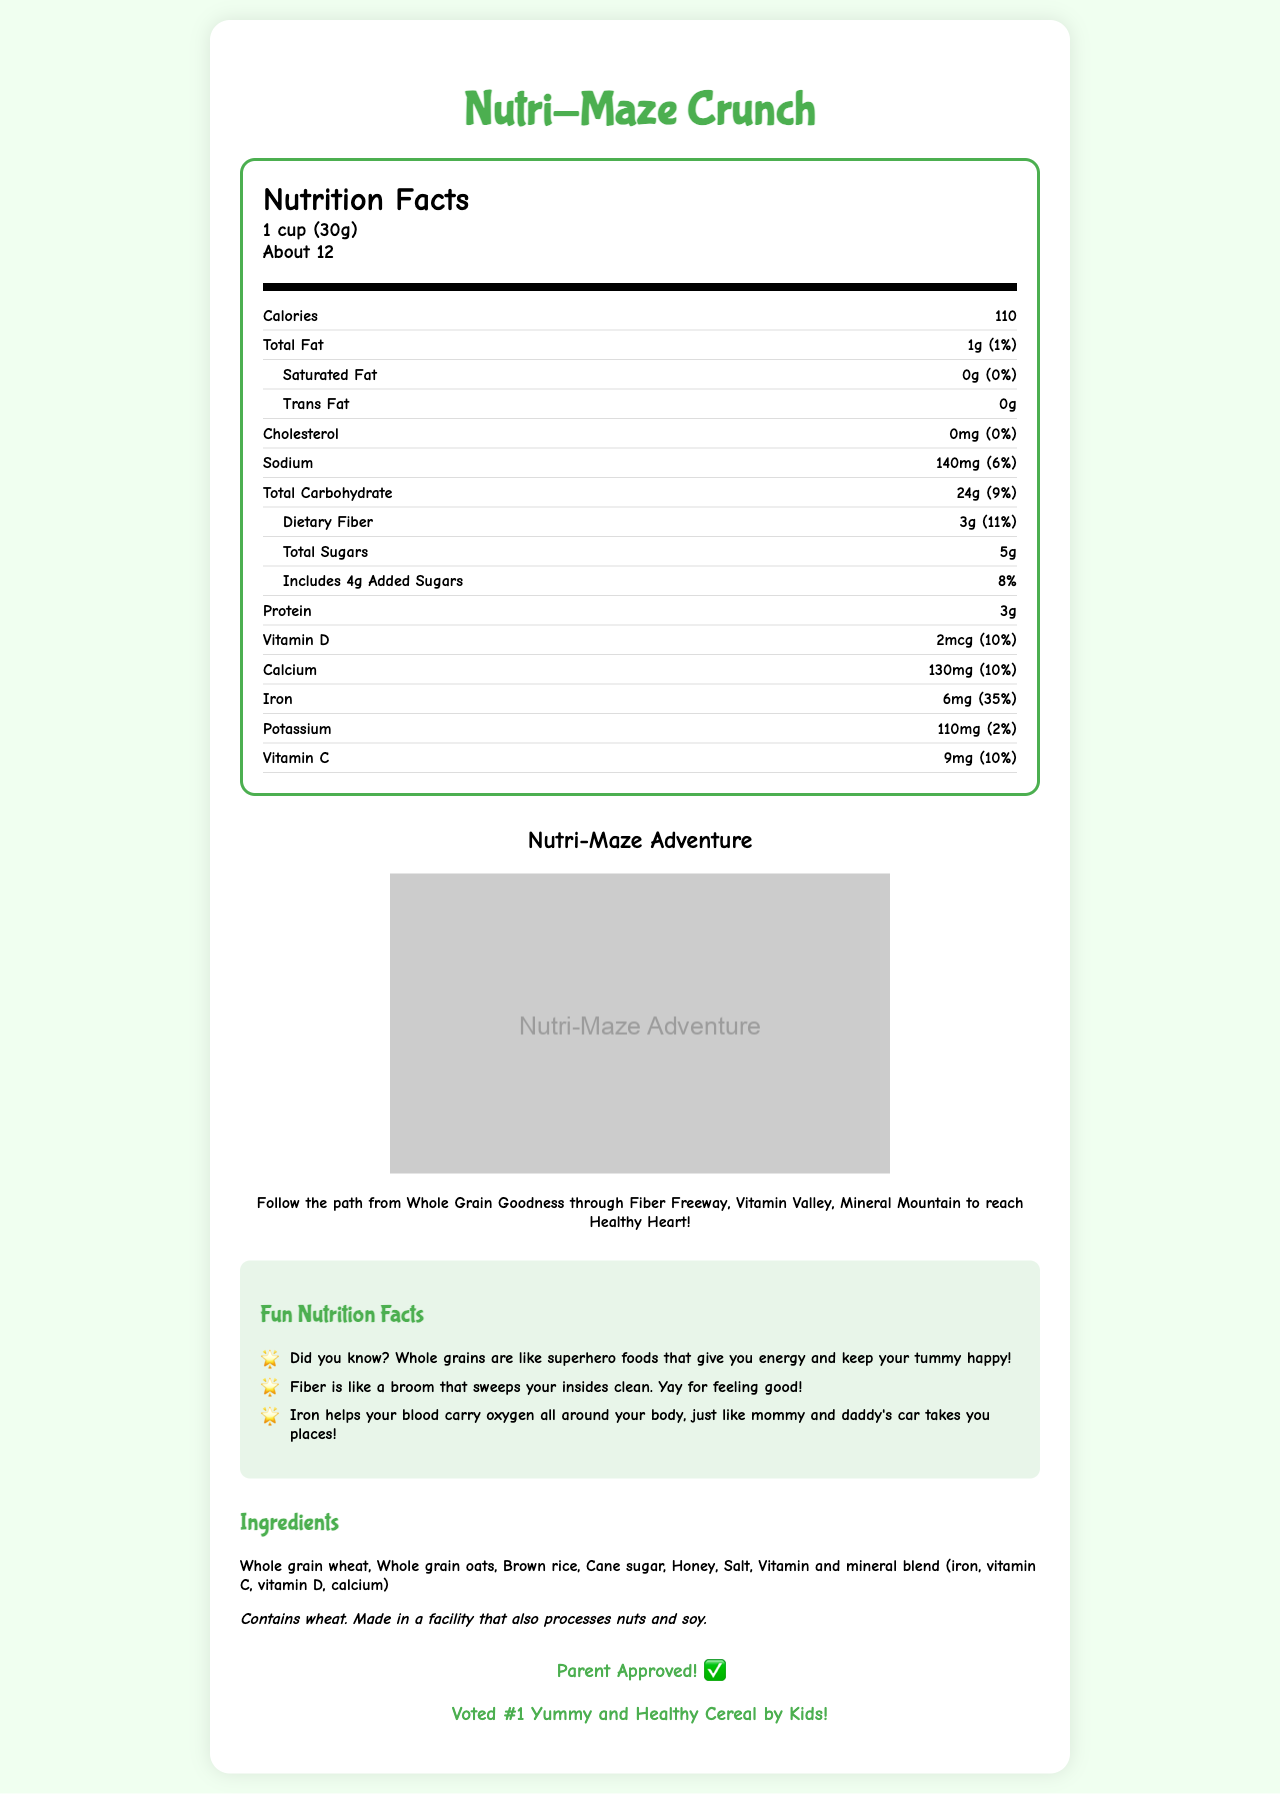what is the serving size? The serving size is clearly listed at the top of the nutrition facts label as "1 cup (30g)".
Answer: 1 cup (30g) how many calories are in one serving? The calories per serving is specified right after the serving size, indicating 110 calories per serving.
Answer: 110 which ingredient is listed first? The first ingredient listed in the ingredients section is "Whole grain wheat", indicating it is the main ingredient.
Answer: Whole grain wheat what percentage of daily value does iron provide? The nutrition label specifically indicates that iron provides 35% of the daily value.
Answer: 35% Does this product contain any allergens? The allergen information states that the product contains wheat and is made in a facility that also processes nuts and soy.
Answer: Yes What are the benefits of fiber mentioned in the fun facts? The fun facts mention that fiber keeps your tummy happy and acts like a broom that sweeps your insides clean.
Answer: keeps your tummy happy, acts like a broom that sweeps your insides clean What are the fun facts about whole grains? The fun facts section states, "Whole grains are like superhero foods that give you energy and keep your tummy happy!"
Answer: Whole grains are like superhero foods that give you energy and keep your tummy happy! How much protein is in one serving? The amount of protein per serving is listed as 3g in the nutrition facts label.
Answer: 3g What are the total sugars per serving, and how much of this is added sugars? According to the nutrition label, there are 5g of total sugars per serving, including 4g of added sugars.
Answer: 5g total sugars, 4g added sugars What is the percentage of daily value for Vitamin C in one serving? The nutrition facts table indicates that one serving provides 10% of the daily value for Vitamin C.
Answer: 10% What is the main idea of the Nutri-Maze Crunch document? The document explains Nutri-Maze Crunch, highlighting its nutritious components such as whole grains and fiber, provides a detailed nutrition facts label, offers fun educational facts, and includes a maze for kids along with endorsements from parents and kids.
Answer: Nutri-Maze Crunch is a nutritious whole grain cereal aimed at kids, featuring a detailed nutrition label, fun facts about its ingredients, a maze for adventure, and endorsements for its taste and health benefits. Follow the path from ________ through Fiber Freeway, Vitamin Valley, and Mineral Mountain to reach ________. The maze adventure section instructs to follow the path from Whole Grain Goodness through Fiber Freeway, Vitamin Valley, and Mineral Mountain to reach Healthy Heart.
Answer: Whole Grain Goodness, Healthy Heart Is this product parent-approved? The approval section clearly states "Parent Approved! ✅"
Answer: Yes Which nutrient has the highest percentage daily value? A. Vitamin D B. Iron C. Calcium The nutrition facts label shows that Iron has the highest percentage daily value at 35%.
Answer: B. Iron Which of the following is a sub-nutrient listed under Total Carbohydrate? A. Total Sugars B. Protein C. Vitamin D The nutrition facts label lists Total Sugars as a sub-nutrient under Total Carbohydrate.
Answer: A. Total Sugars How many servings are there in one container? The serving information specifies that there are about 12 servings per container.
Answer: About 12 Does the document mention the exact manufacturing facility location? The document provides allergen information but does not disclose the exact location of the manufacturing facility.
Answer: Not enough information Describe the maze adventure section with one sentence. The section describes starting from Whole Grain Goodness, going through Fiber Freeway, Vitamin Valley, and Mineral Mountain, and ending at a Healthy Heart.
Answer: The maze adventure section encourages kids to follow a path from Whole Grain Goodness through various checkpoints to reach a Healthy Heart. 